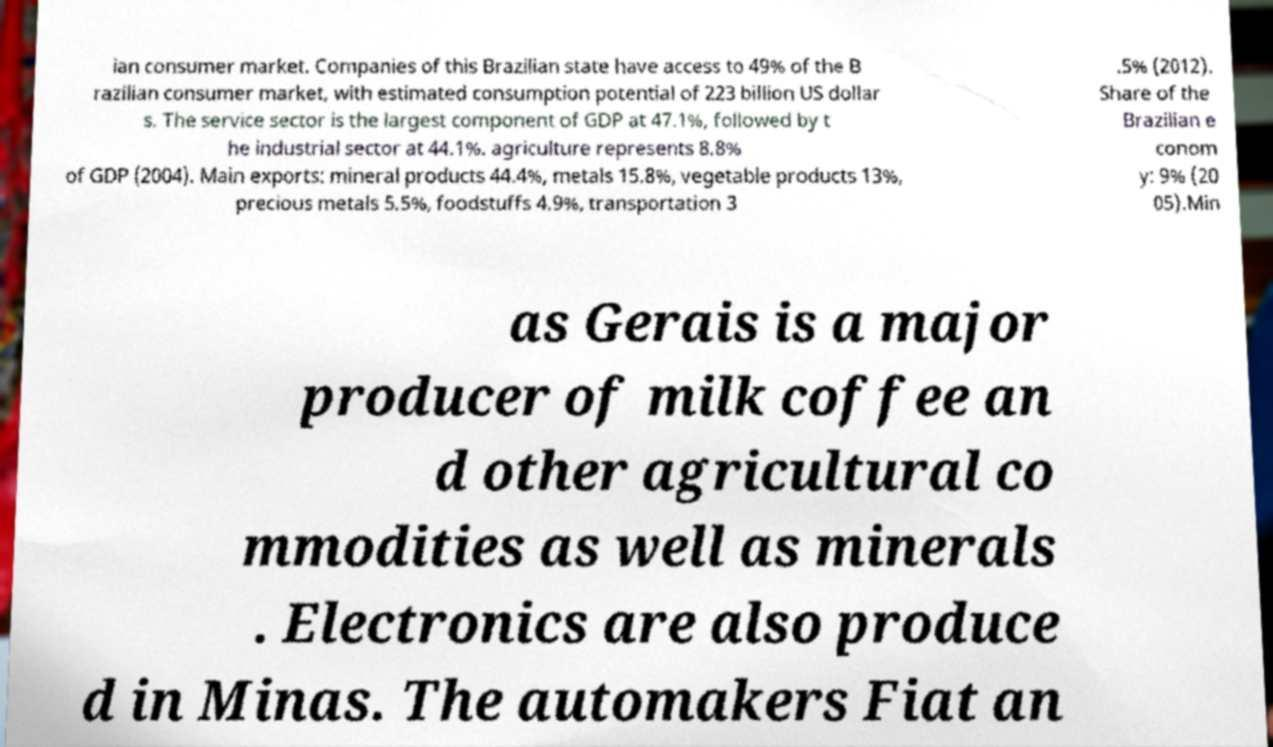Can you accurately transcribe the text from the provided image for me? ian consumer market. Companies of this Brazilian state have access to 49% of the B razilian consumer market, with estimated consumption potential of 223 billion US dollar s. The service sector is the largest component of GDP at 47.1%, followed by t he industrial sector at 44.1%. agriculture represents 8.8% of GDP (2004). Main exports: mineral products 44.4%, metals 15.8%, vegetable products 13%, precious metals 5.5%, foodstuffs 4.9%, transportation 3 .5% (2012). Share of the Brazilian e conom y: 9% (20 05).Min as Gerais is a major producer of milk coffee an d other agricultural co mmodities as well as minerals . Electronics are also produce d in Minas. The automakers Fiat an 